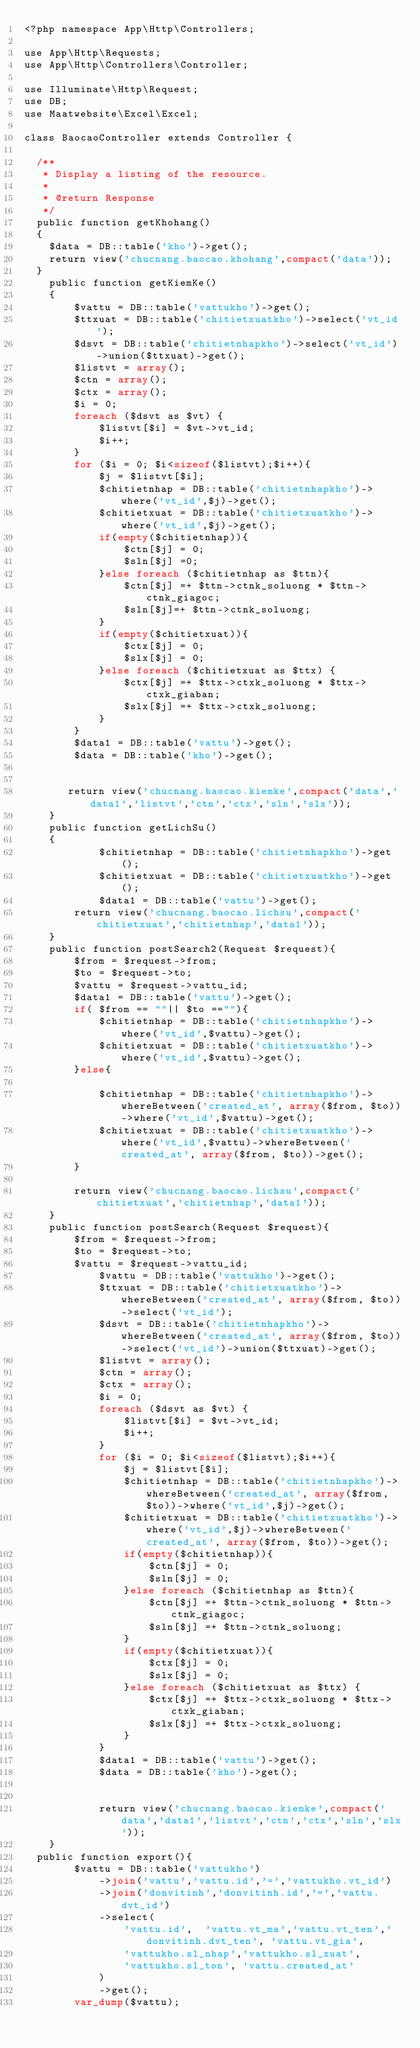<code> <loc_0><loc_0><loc_500><loc_500><_PHP_><?php namespace App\Http\Controllers;

use App\Http\Requests;
use App\Http\Controllers\Controller;

use Illuminate\Http\Request;
use DB;
use Maatwebsite\Excel\Excel;

class BaocaoController extends Controller {

	/**
	 * Display a listing of the resource.
	 *
	 * @return Response
	 */
	public function getKhohang()
	{
		$data = DB::table('kho')->get();
		return view('chucnang.baocao.khohang',compact('data'));
	}
    public function getKiemKe()
    {
        $vattu = DB::table('vattukho')->get();
        $ttxuat = DB::table('chitietxuatkho')->select('vt_id');
        $dsvt = DB::table('chitietnhapkho')->select('vt_id')->union($ttxuat)->get();
        $listvt = array();
        $ctn = array();
        $ctx = array();
        $i = 0;
        foreach ($dsvt as $vt) {
            $listvt[$i] = $vt->vt_id;
            $i++;
        }
        for ($i = 0; $i<sizeof($listvt);$i++){
            $j = $listvt[$i];
            $chitietnhap = DB::table('chitietnhapkho')->where('vt_id',$j)->get();
            $chitietxuat = DB::table('chitietxuatkho')->where('vt_id',$j)->get();
            if(empty($chitietnhap)){
                $ctn[$j] = 0;
                $sln[$j] =0;
            }else foreach ($chitietnhap as $ttn){
                $ctn[$j] =+ $ttn->ctnk_soluong * $ttn->ctnk_giagoc;
                $sln[$j]=+ $ttn->ctnk_soluong;
            }
            if(empty($chitietxuat)){
                $ctx[$j] = 0;
                $slx[$j] = 0;
            }else foreach ($chitietxuat as $ttx) {
                $ctx[$j] =+ $ttx->ctxk_soluong * $ttx->ctxk_giaban;
                $slx[$j] =+ $ttx->ctxk_soluong;
            }
        }
        $data1 = DB::table('vattu')->get();
        $data = DB::table('kho')->get();


       return view('chucnang.baocao.kiemke',compact('data','data1','listvt','ctn','ctx','sln','slx'));
    }
    public function getLichSu()
    {
            $chitietnhap = DB::table('chitietnhapkho')->get();
            $chitietxuat = DB::table('chitietxuatkho')->get();
            $data1 = DB::table('vattu')->get();
        return view('chucnang.baocao.lichsu',compact('chitietxuat','chitietnhap','data1'));
    }
    public function postSearch2(Request $request){
        $from = $request->from;
        $to = $request->to;
        $vattu = $request->vattu_id;
        $data1 = DB::table('vattu')->get();
        if( $from == ""|| $to ==""){
            $chitietnhap = DB::table('chitietnhapkho')->where('vt_id',$vattu)->get();
            $chitietxuat = DB::table('chitietxuatkho')->where('vt_id',$vattu)->get();
        }else{

            $chitietnhap = DB::table('chitietnhapkho')->whereBetween('created_at', array($from, $to))->where('vt_id',$vattu)->get();
            $chitietxuat = DB::table('chitietxuatkho')->where('vt_id',$vattu)->whereBetween('created_at', array($from, $to))->get();
        }

        return view('chucnang.baocao.lichsu',compact('chitietxuat','chitietnhap','data1'));
    }
    public function postSearch(Request $request){
        $from = $request->from;
        $to = $request->to;
        $vattu = $request->vattu_id;
            $vattu = DB::table('vattukho')->get();
            $ttxuat = DB::table('chitietxuatkho')->whereBetween('created_at', array($from, $to))->select('vt_id');
            $dsvt = DB::table('chitietnhapkho')->whereBetween('created_at', array($from, $to))->select('vt_id')->union($ttxuat)->get();
            $listvt = array();
            $ctn = array();
            $ctx = array();
            $i = 0;
            foreach ($dsvt as $vt) {
                $listvt[$i] = $vt->vt_id;
                $i++;
            }
            for ($i = 0; $i<sizeof($listvt);$i++){
                $j = $listvt[$i];
                $chitietnhap = DB::table('chitietnhapkho')->whereBetween('created_at', array($from, $to))->where('vt_id',$j)->get();
                $chitietxuat = DB::table('chitietxuatkho')->where('vt_id',$j)->whereBetween('created_at', array($from, $to))->get();
                if(empty($chitietnhap)){
                    $ctn[$j] = 0;
                    $sln[$j] = 0;
                }else foreach ($chitietnhap as $ttn){
                    $ctn[$j] =+ $ttn->ctnk_soluong * $ttn->ctnk_giagoc;
                    $sln[$j] =+ $ttn->ctnk_soluong;
                }
                if(empty($chitietxuat)){
                    $ctx[$j] = 0;
                    $slx[$j] = 0;
                }else foreach ($chitietxuat as $ttx) {
                    $ctx[$j] =+ $ttx->ctxk_soluong * $ttx->ctxk_giaban;
                    $slx[$j] =+ $ttx->ctxk_soluong;
                }
            }
            $data1 = DB::table('vattu')->get();
            $data = DB::table('kho')->get();


            return view('chucnang.baocao.kiemke',compact('data','data1','listvt','ctn','ctx','sln','slx'));
    }
	public function export(){
        $vattu = DB::table('vattukho')
            ->join('vattu','vattu.id','=','vattukho.vt_id')
            ->join('donvitinh','donvitinh.id','=','vattu.dvt_id')
            ->select(
                'vattu.id',  'vattu.vt_ma','vattu.vt_ten','donvitinh.dvt_ten', 'vattu.vt_gia',
                'vattukho.sl_nhap','vattukho.sl_xuat',
                'vattukho.sl_ton', 'vattu.created_at'
            )
            ->get();
        var_dump($vattu);</code> 